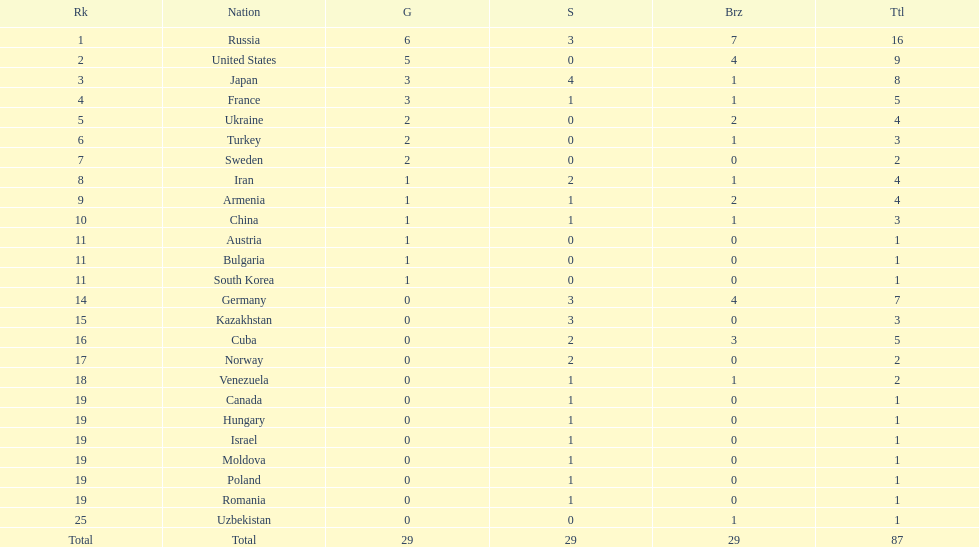Japan and france each won how many gold medals? 3. 